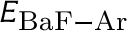<formula> <loc_0><loc_0><loc_500><loc_500>E _ { B a F - A r }</formula> 